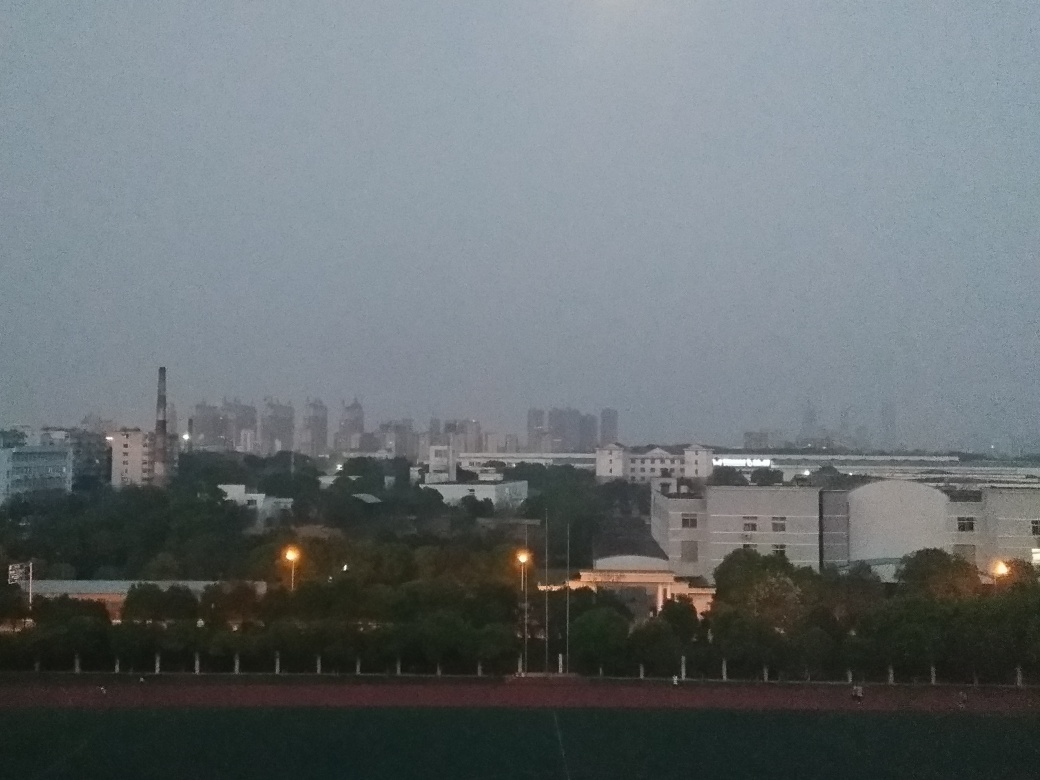What time of day does this image seem to represent? The image appears to depict twilight or early evening, characterized by the low ambient light and the absence of direct sunlight on the buildings. Can you describe the types of buildings we see? The skyline features a mix of industrial structures, including smokestacks and possibly manufacturing facilities, as well as residential or commercial high-rise buildings in the distance. The foreground includes a sports field and a few low-rise buildings. 